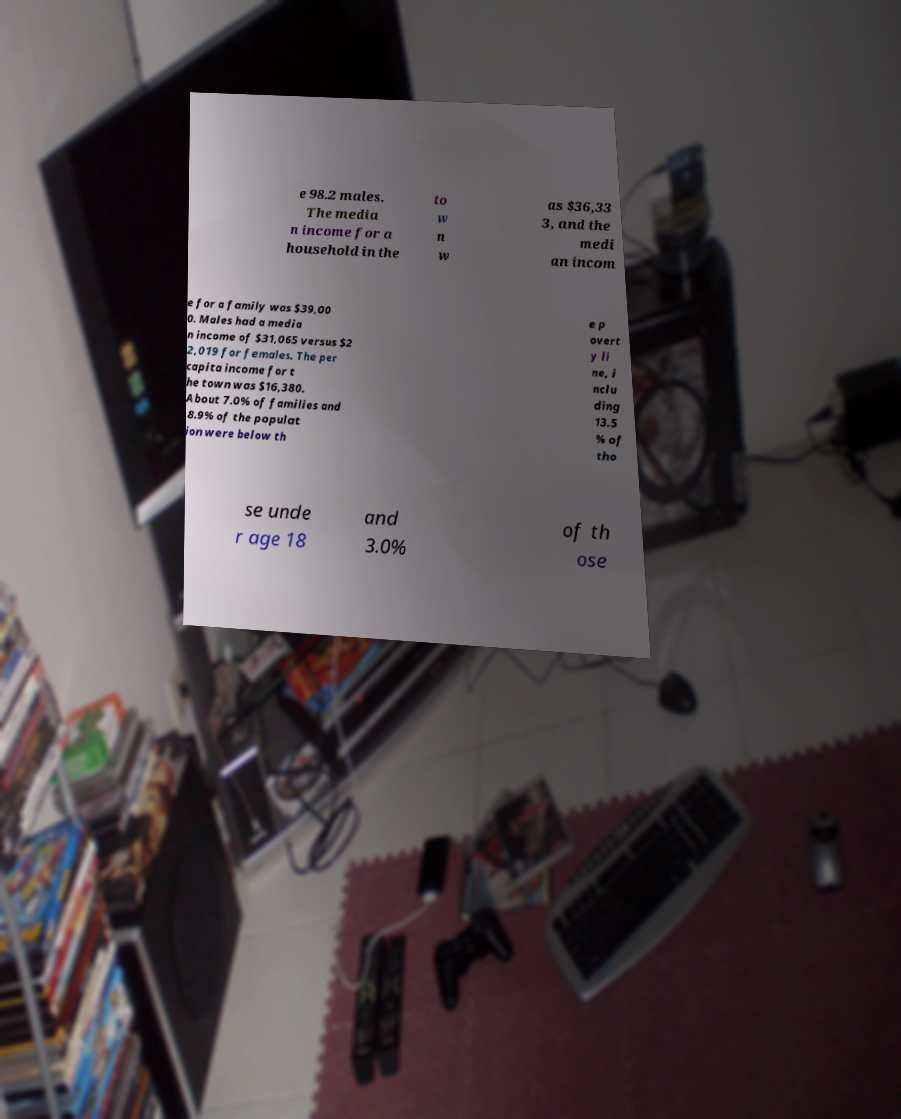Please read and relay the text visible in this image. What does it say? e 98.2 males. The media n income for a household in the to w n w as $36,33 3, and the medi an incom e for a family was $39,00 0. Males had a media n income of $31,065 versus $2 2,019 for females. The per capita income for t he town was $16,380. About 7.0% of families and 8.9% of the populat ion were below th e p overt y li ne, i nclu ding 13.5 % of tho se unde r age 18 and 3.0% of th ose 